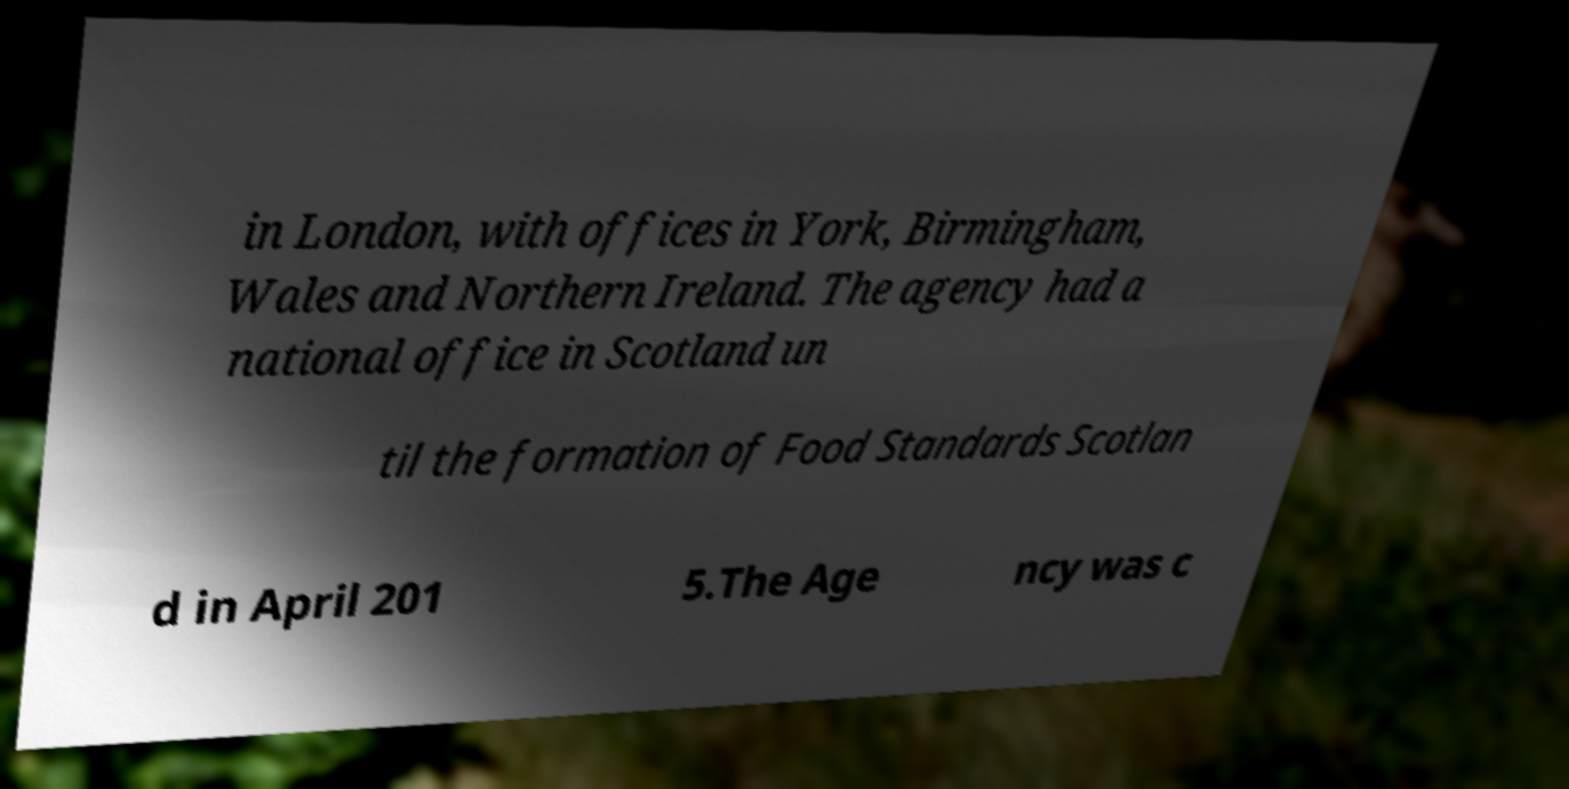Could you extract and type out the text from this image? in London, with offices in York, Birmingham, Wales and Northern Ireland. The agency had a national office in Scotland un til the formation of Food Standards Scotlan d in April 201 5.The Age ncy was c 